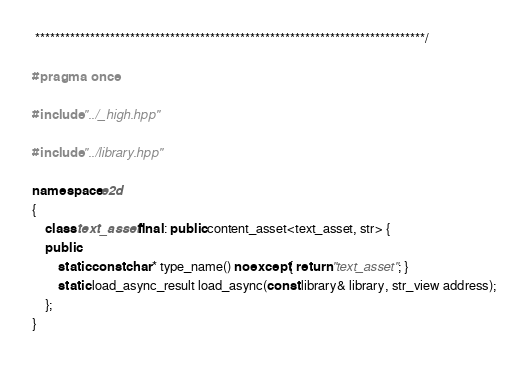<code> <loc_0><loc_0><loc_500><loc_500><_C++_> ******************************************************************************/

#pragma once

#include "../_high.hpp"

#include "../library.hpp"

namespace e2d
{
    class text_asset final : public content_asset<text_asset, str> {
    public:
        static const char* type_name() noexcept { return "text_asset"; }
        static load_async_result load_async(const library& library, str_view address);
    };
}
</code> 